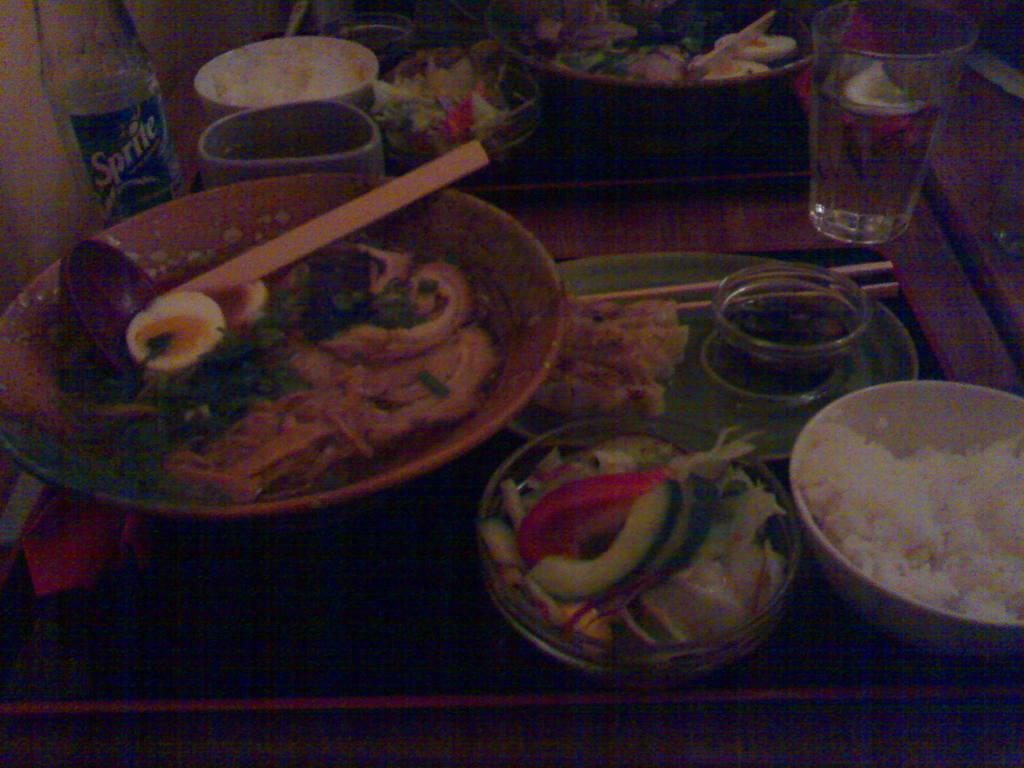What type of objects are present in the image that contain food? There are bowls in the image that contain food. What colors can be seen in the food items? The food has cream, green, and red colors. What type of beverage containers are in the image? There are glasses and bottles in the image. What is the color of the surface in the image? The surface in the image is brown. Are there any dinosaurs visible in the image? No, there are no dinosaurs present in the image. Can you tell me how much money is on the brown surface in the image? There is no mention of money in the image; it only features food items, bowls, glasses, bottles, and a brown surface. 